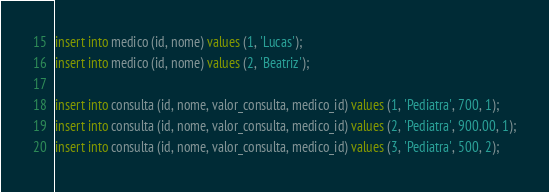Convert code to text. <code><loc_0><loc_0><loc_500><loc_500><_SQL_>insert into medico (id, nome) values (1, 'Lucas');
insert into medico (id, nome) values (2, 'Beatriz');

insert into consulta (id, nome, valor_consulta, medico_id) values (1, 'Pediatra', 700, 1);
insert into consulta (id, nome, valor_consulta, medico_id) values (2, 'Pediatra', 900.00, 1);
insert into consulta (id, nome, valor_consulta, medico_id) values (3, 'Pediatra', 500, 2);


</code> 